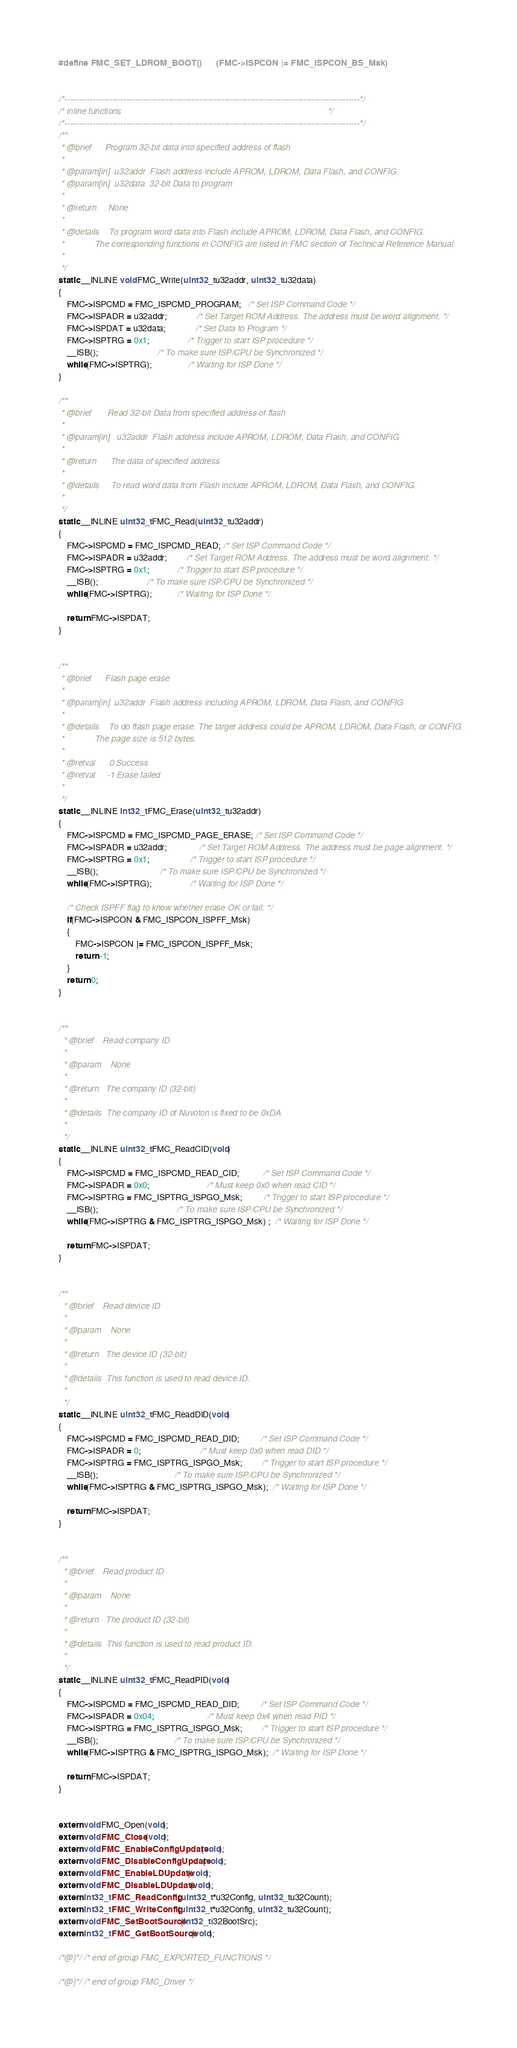Convert code to text. <code><loc_0><loc_0><loc_500><loc_500><_C_>#define FMC_SET_LDROM_BOOT()      (FMC->ISPCON |= FMC_ISPCON_BS_Msk)


/*---------------------------------------------------------------------------------------------------------*/
/* inline functions                                                                                        */
/*---------------------------------------------------------------------------------------------------------*/
/**
 * @brief      Program 32-bit data into specified address of flash
 *
 * @param[in]  u32addr  Flash address include APROM, LDROM, Data Flash, and CONFIG
 * @param[in]  u32data  32-bit Data to program
 *
 * @return     None
 *
 * @details    To program word data into Flash include APROM, LDROM, Data Flash, and CONFIG.
 *             The corresponding functions in CONFIG are listed in FMC section of Technical Reference Manual.
 *
 */
static __INLINE void FMC_Write(uint32_t u32addr, uint32_t u32data)
{
    FMC->ISPCMD = FMC_ISPCMD_PROGRAM;   /* Set ISP Command Code */
    FMC->ISPADR = u32addr;              /* Set Target ROM Address. The address must be word alignment. */
    FMC->ISPDAT = u32data;              /* Set Data to Program */
    FMC->ISPTRG = 0x1;                  /* Trigger to start ISP procedure */
    __ISB();                            /* To make sure ISP/CPU be Synchronized */
    while(FMC->ISPTRG);                 /* Waiting for ISP Done */
}

/**
 * @brief       Read 32-bit Data from specified address of flash
 *
 * @param[in]   u32addr  Flash address include APROM, LDROM, Data Flash, and CONFIG
 *
 * @return      The data of specified address
 *
 * @details     To read word data from Flash include APROM, LDROM, Data Flash, and CONFIG.
 *
 */
static __INLINE uint32_t FMC_Read(uint32_t u32addr)
{
    FMC->ISPCMD = FMC_ISPCMD_READ; /* Set ISP Command Code */
    FMC->ISPADR = u32addr;         /* Set Target ROM Address. The address must be word alignment. */
    FMC->ISPTRG = 0x1;             /* Trigger to start ISP procedure */
    __ISB();                       /* To make sure ISP/CPU be Synchronized */
    while(FMC->ISPTRG);            /* Waiting for ISP Done */

    return FMC->ISPDAT;
}


/**
 * @brief      Flash page erase
 *
 * @param[in]  u32addr  Flash address including APROM, LDROM, Data Flash, and CONFIG
 *
 * @details    To do flash page erase. The target address could be APROM, LDROM, Data Flash, or CONFIG.
 *             The page size is 512 bytes.
 *
 * @retval      0 Success
 * @retval     -1 Erase failed
 *
 */
static __INLINE int32_t FMC_Erase(uint32_t u32addr)
{
    FMC->ISPCMD = FMC_ISPCMD_PAGE_ERASE; /* Set ISP Command Code */
    FMC->ISPADR = u32addr;               /* Set Target ROM Address. The address must be page alignment. */
    FMC->ISPTRG = 0x1;                   /* Trigger to start ISP procedure */
    __ISB();                             /* To make sure ISP/CPU be Synchronized */
    while(FMC->ISPTRG);                  /* Waiting for ISP Done */

    /* Check ISPFF flag to know whether erase OK or fail. */
    if(FMC->ISPCON & FMC_ISPCON_ISPFF_Msk)
    {
        FMC->ISPCON |= FMC_ISPCON_ISPFF_Msk;
        return -1;
    }
    return 0;
}


/**
  * @brief    Read company ID
  *
  * @param    None
  *
  * @return   The company ID (32-bit)
  *
  * @details  The company ID of Nuvoton is fixed to be 0xDA
  *
  */
static __INLINE uint32_t FMC_ReadCID(void)
{
    FMC->ISPCMD = FMC_ISPCMD_READ_CID;           /* Set ISP Command Code */
    FMC->ISPADR = 0x0;                           /* Must keep 0x0 when read CID */
    FMC->ISPTRG = FMC_ISPTRG_ISPGO_Msk;          /* Trigger to start ISP procedure */
    __ISB();                                     /* To make sure ISP/CPU be Synchronized */
    while(FMC->ISPTRG & FMC_ISPTRG_ISPGO_Msk) ;  /* Waiting for ISP Done */

    return FMC->ISPDAT;
}


/**
  * @brief    Read device ID
  *
  * @param    None
  *
  * @return   The device ID (32-bit)
  *
  * @details  This function is used to read device ID.
  *
  */
static __INLINE uint32_t FMC_ReadDID(void)
{
    FMC->ISPCMD = FMC_ISPCMD_READ_DID;          /* Set ISP Command Code */
    FMC->ISPADR = 0;                            /* Must keep 0x0 when read DID */
    FMC->ISPTRG = FMC_ISPTRG_ISPGO_Msk;         /* Trigger to start ISP procedure */
    __ISB();                                    /* To make sure ISP/CPU be Synchronized */
    while(FMC->ISPTRG & FMC_ISPTRG_ISPGO_Msk);  /* Waiting for ISP Done */

    return FMC->ISPDAT;
}


/**
  * @brief    Read product ID
  *
  * @param    None
  *
  * @return   The product ID (32-bit)
  *
  * @details  This function is used to read product ID.
  *
  */
static __INLINE uint32_t FMC_ReadPID(void)
{
    FMC->ISPCMD = FMC_ISPCMD_READ_DID;          /* Set ISP Command Code */
    FMC->ISPADR = 0x04;                         /* Must keep 0x4 when read PID */
    FMC->ISPTRG = FMC_ISPTRG_ISPGO_Msk;         /* Trigger to start ISP procedure */
    __ISB();                                    /* To make sure ISP/CPU be Synchronized */
    while(FMC->ISPTRG & FMC_ISPTRG_ISPGO_Msk);  /* Waiting for ISP Done */

    return FMC->ISPDAT;
}


extern void FMC_Open(void);
extern void FMC_Close(void);
extern void FMC_EnableConfigUpdate(void);
extern void FMC_DisableConfigUpdate(void);
extern void FMC_EnableLDUpdate(void);
extern void FMC_DisableLDUpdate(void);
extern int32_t FMC_ReadConfig(uint32_t *u32Config, uint32_t u32Count);
extern int32_t FMC_WriteConfig(uint32_t *u32Config, uint32_t u32Count);
extern void FMC_SetBootSource(int32_t i32BootSrc);
extern int32_t FMC_GetBootSource(void);

/*@}*/ /* end of group FMC_EXPORTED_FUNCTIONS */

/*@}*/ /* end of group FMC_Driver */
</code> 